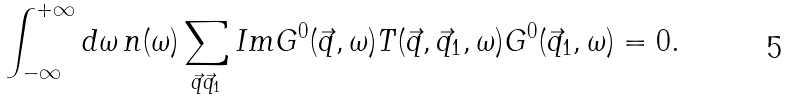<formula> <loc_0><loc_0><loc_500><loc_500>\int _ { - \infty } ^ { + \infty } d \omega \, n ( \omega ) \sum _ { \vec { q } \vec { q } _ { 1 } } I m G ^ { 0 } ( \vec { q } , \omega ) T ( \vec { q } , \vec { q } _ { 1 } , \omega ) G ^ { 0 } ( \vec { q } _ { 1 } , \omega ) = 0 .</formula> 